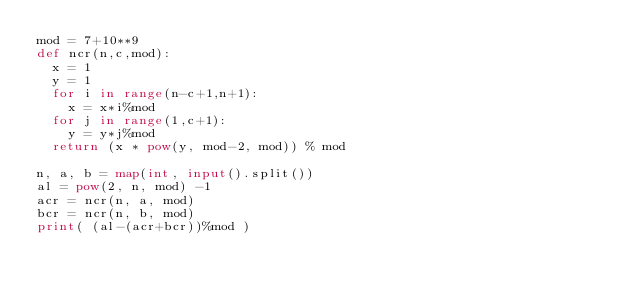Convert code to text. <code><loc_0><loc_0><loc_500><loc_500><_Python_>mod = 7+10**9
def ncr(n,c,mod):
  x = 1
  y = 1
  for i in range(n-c+1,n+1):
    x = x*i%mod
  for j in range(1,c+1):
    y = y*j%mod
  return (x * pow(y, mod-2, mod)) % mod

n, a, b = map(int, input().split())
al = pow(2, n, mod) -1
acr = ncr(n, a, mod)
bcr = ncr(n, b, mod)
print( (al-(acr+bcr))%mod )</code> 